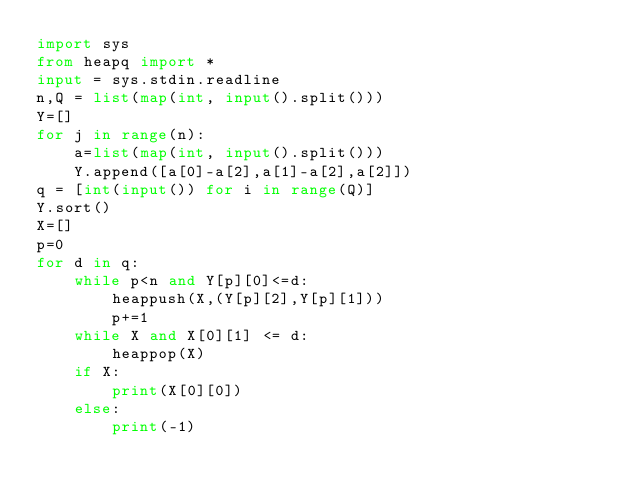<code> <loc_0><loc_0><loc_500><loc_500><_Python_>import sys
from heapq import *
input = sys.stdin.readline
n,Q = list(map(int, input().split()))
Y=[]
for j in range(n):
    a=list(map(int, input().split()))
    Y.append([a[0]-a[2],a[1]-a[2],a[2]])
q = [int(input()) for i in range(Q)]
Y.sort()
X=[]
p=0
for d in q:
    while p<n and Y[p][0]<=d:
        heappush(X,(Y[p][2],Y[p][1]))
        p+=1
    while X and X[0][1] <= d:
        heappop(X)
    if X:
        print(X[0][0])
    else:
        print(-1)

</code> 